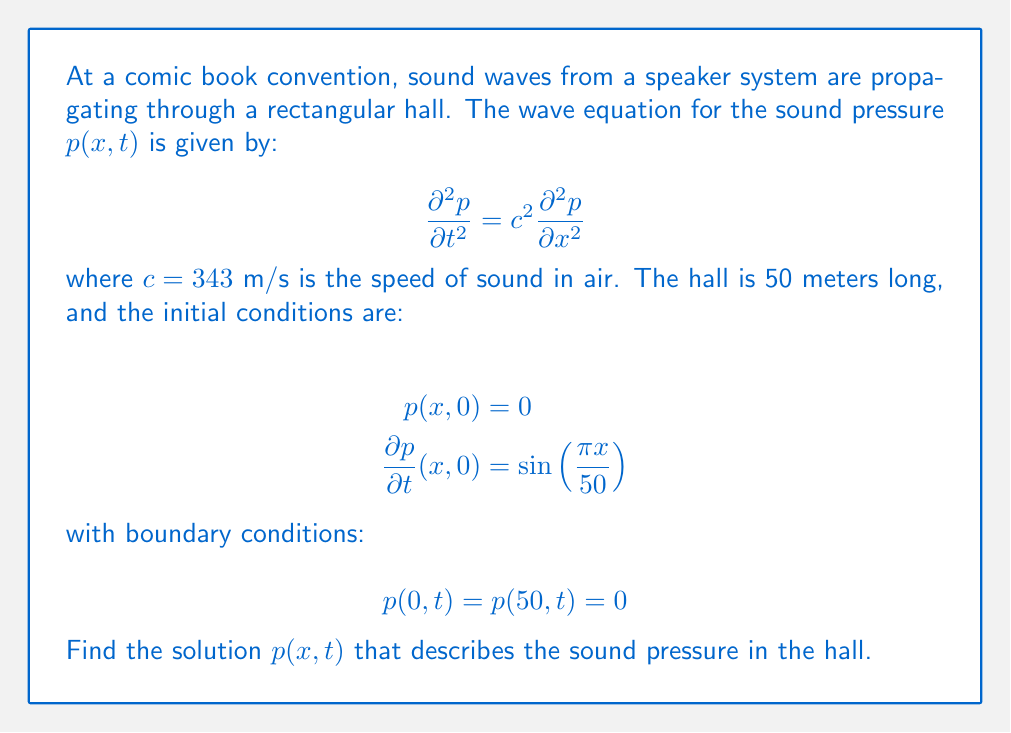Solve this math problem. To solve this wave equation, we'll use the method of separation of variables and follow these steps:

1) Assume a solution of the form $p(x,t) = X(x)T(t)$.

2) Substituting this into the wave equation:

   $$X(x)T''(t) = c^2X''(x)T(t)$$

3) Dividing by $X(x)T(t)$:

   $$\frac{T''(t)}{T(t)} = c^2\frac{X''(x)}{X(x)} = -\lambda$$

   where $\lambda$ is a constant.

4) This gives us two ordinary differential equations:

   $$X''(x) + \frac{\lambda}{c^2}X(x) = 0$$
   $$T''(t) + \lambda T(t) = 0$$

5) The boundary conditions $p(0,t) = p(50,t) = 0$ imply $X(0) = X(50) = 0$. This, along with the first equation in step 4, forms a Sturm-Liouville problem with eigenvalues:

   $$\lambda_n = (\frac{n\pi c}{50})^2, n = 1,2,3,...$$

   and corresponding eigenfunctions:

   $$X_n(x) = \sin(\frac{n\pi x}{50})$$

6) The general solution for $T_n(t)$ is:

   $$T_n(t) = A_n\cos(\frac{n\pi c}{50}t) + B_n\sin(\frac{n\pi c}{50}t)$$

7) The general solution for $p(x,t)$ is:

   $$p(x,t) = \sum_{n=1}^{\infty} [A_n\cos(\frac{n\pi c}{50}t) + B_n\sin(\frac{n\pi c}{50}t)]\sin(\frac{n\pi x}{50})$$

8) Using the initial condition $p(x,0) = 0$, we get $A_n = 0$ for all $n$.

9) Using the initial condition $\frac{\partial p}{\partial t}(x,0) = \sin(\frac{\pi x}{50})$, we get:

   $$\sum_{n=1}^{\infty} B_n\frac{n\pi c}{50}\sin(\frac{n\pi x}{50}) = \sin(\frac{\pi x}{50})$$

   This implies $B_1 = \frac{50}{\pi c}$ and $B_n = 0$ for $n > 1$.

10) Therefore, the final solution is:

    $$p(x,t) = \frac{50}{\pi c}\sin(\frac{\pi c}{50}t)\sin(\frac{\pi x}{50})$$
Answer: $$p(x,t) = \frac{50}{\pi c}\sin(\frac{\pi c}{50}t)\sin(\frac{\pi x}{50})$$
where $c = 343$ m/s 